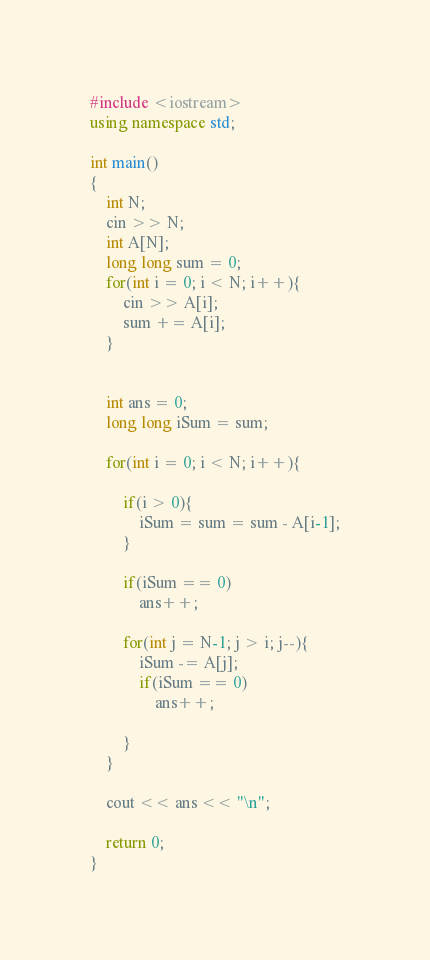Convert code to text. <code><loc_0><loc_0><loc_500><loc_500><_C++_>#include <iostream>
using namespace std;

int main()
{
	int N;
	cin >> N;
	int A[N];
	long long sum = 0;
	for(int i = 0; i < N; i++){
		cin >> A[i];
		sum += A[i];
	}


	int ans = 0;
	long long iSum = sum;
	
	for(int i = 0; i < N; i++){

		if(i > 0){
			iSum = sum = sum - A[i-1];
		}

		if(iSum == 0)
			ans++;
		
		for(int j = N-1; j > i; j--){
			iSum -= A[j];
			if(iSum == 0)
				ans++;

		}
	}

	cout << ans << "\n";

	return 0;
}
</code> 